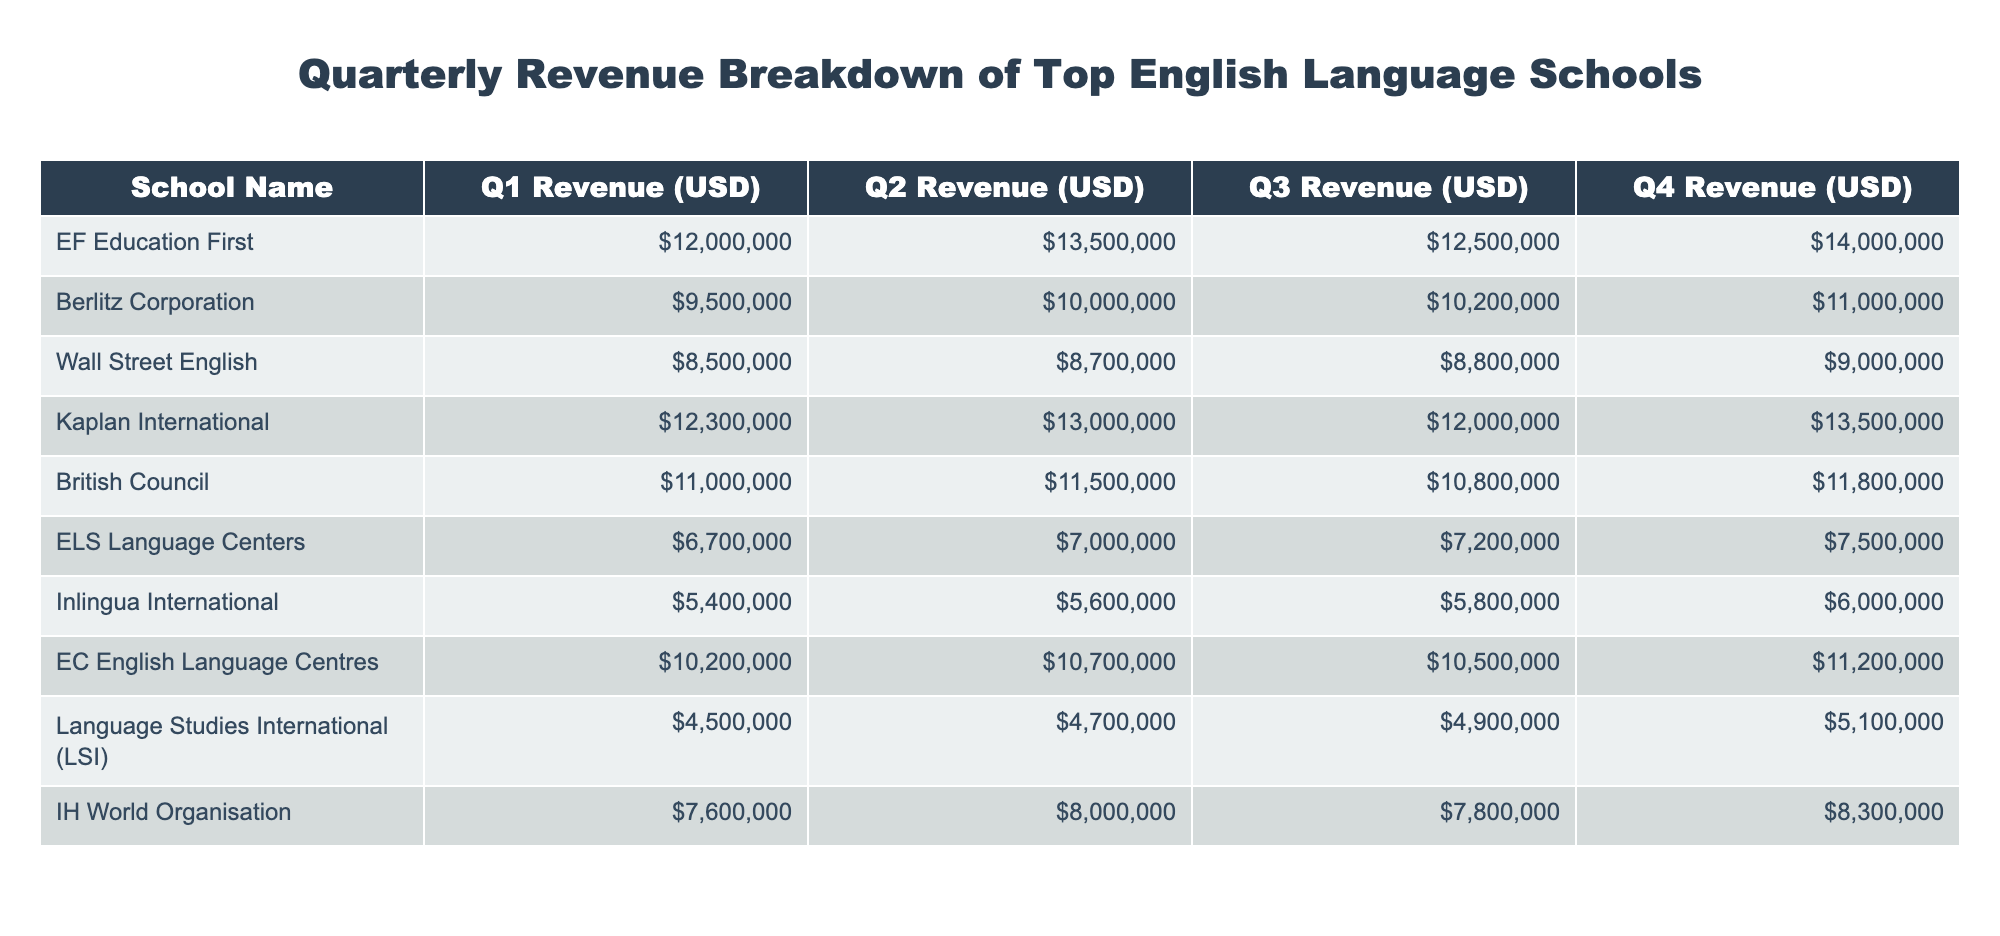What was the total revenue for EF Education First in Q3? According to the table, the revenue for EF Education First in Q3 is listed as $12,500,000.
Answer: $12,500,000 Which school had the lowest revenue in Q2? From the table, ELS Language Centers had the lowest revenue in Q2 with $7,000,000.
Answer: ELS Language Centers What was the average revenue for Kaplan International over the four quarters? To find the average, sum Kaplan International's revenues across all quarters: $12,300,000 + $13,000,000 + $12,000,000 + $13,500,000 = $50,800,000. Dividing this by 4 gives an average of $12,700,000.
Answer: $12,700,000 Did any school have an increase in revenue every quarter? By examining the revenues for each school, we see that Kaplan International increased every quarter: Q1 to Q2, Q2 to Q3, and Q3 to Q4.
Answer: Yes What is the total revenue of all schools in Q1? For Q1, add the revenue from all schools: $12,000,000 (EF Education First) + $9,500,000 (Berlitz Corporation) + $8,500,000 (Wall Street English) + $12,300,000 (Kaplan International) + $11,000,000 (British Council) + $6,700,000 (ELS Language Centers) + $5,400,000 (Inlingua International) + $10,200,000 (EC English Language Centres) + $4,500,000 (Language Studies International) + $7,600,000 (IH World Organisation) = $ 78,200,000.
Answer: $78,200,000 What was the percentage increase in revenue for Wall Street English from Q3 to Q4? The revenue for Wall Street English in Q3 is $8,800,000 and in Q4 is $9,000,000. The increase is: $9,000,000 - $8,800,000 = $200,000. Now, calculate the percentage increase: ($200,000 / $8,800,000) * 100 = 2.27%.
Answer: 2.27% 